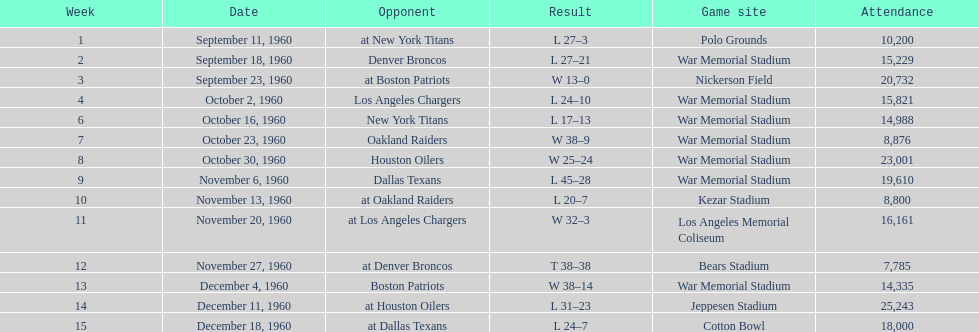What was the largest point margin in a single contest? 29. 